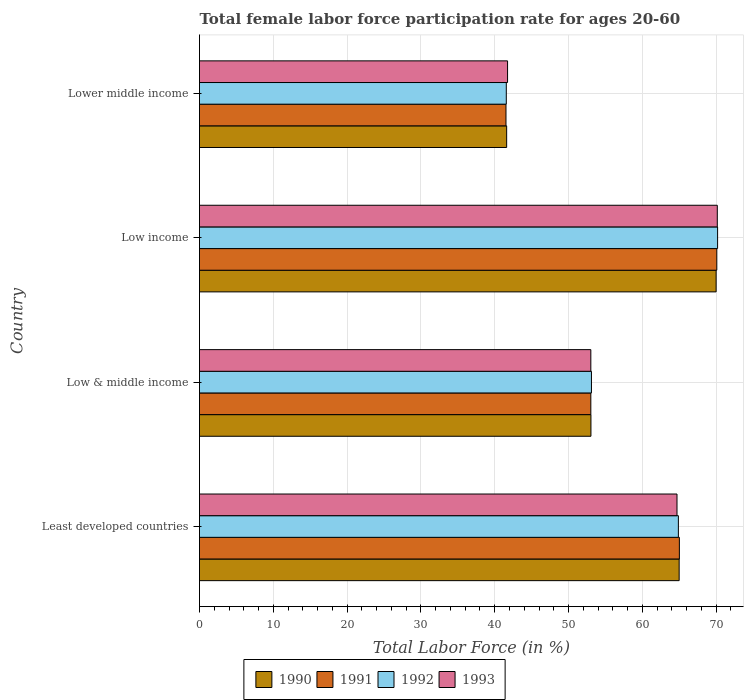How many different coloured bars are there?
Offer a terse response. 4. Are the number of bars per tick equal to the number of legend labels?
Your answer should be very brief. Yes. How many bars are there on the 3rd tick from the bottom?
Offer a very short reply. 4. In how many cases, is the number of bars for a given country not equal to the number of legend labels?
Offer a terse response. 0. What is the female labor force participation rate in 1991 in Lower middle income?
Your response must be concise. 41.53. Across all countries, what is the maximum female labor force participation rate in 1993?
Your answer should be very brief. 70.16. Across all countries, what is the minimum female labor force participation rate in 1990?
Your response must be concise. 41.62. In which country was the female labor force participation rate in 1990 maximum?
Keep it short and to the point. Low income. In which country was the female labor force participation rate in 1993 minimum?
Provide a short and direct response. Lower middle income. What is the total female labor force participation rate in 1991 in the graph?
Your response must be concise. 229.66. What is the difference between the female labor force participation rate in 1990 in Low & middle income and that in Lower middle income?
Offer a very short reply. 11.42. What is the difference between the female labor force participation rate in 1992 in Lower middle income and the female labor force participation rate in 1993 in Low income?
Provide a short and direct response. -28.59. What is the average female labor force participation rate in 1991 per country?
Your answer should be compact. 57.41. What is the difference between the female labor force participation rate in 1990 and female labor force participation rate in 1993 in Low income?
Your answer should be compact. -0.16. What is the ratio of the female labor force participation rate in 1990 in Least developed countries to that in Lower middle income?
Keep it short and to the point. 1.56. Is the female labor force participation rate in 1993 in Least developed countries less than that in Low & middle income?
Your response must be concise. No. What is the difference between the highest and the second highest female labor force participation rate in 1991?
Make the answer very short. 5.07. What is the difference between the highest and the lowest female labor force participation rate in 1990?
Offer a terse response. 28.38. What does the 2nd bar from the top in Least developed countries represents?
Offer a very short reply. 1992. What does the 1st bar from the bottom in Least developed countries represents?
Ensure brevity in your answer.  1990. How many countries are there in the graph?
Offer a terse response. 4. Does the graph contain any zero values?
Ensure brevity in your answer.  No. Does the graph contain grids?
Ensure brevity in your answer.  Yes. How many legend labels are there?
Offer a terse response. 4. How are the legend labels stacked?
Ensure brevity in your answer.  Horizontal. What is the title of the graph?
Make the answer very short. Total female labor force participation rate for ages 20-60. Does "1971" appear as one of the legend labels in the graph?
Provide a short and direct response. No. What is the label or title of the X-axis?
Make the answer very short. Total Labor Force (in %). What is the Total Labor Force (in %) of 1990 in Least developed countries?
Provide a succinct answer. 64.99. What is the Total Labor Force (in %) in 1991 in Least developed countries?
Ensure brevity in your answer.  65.02. What is the Total Labor Force (in %) of 1992 in Least developed countries?
Provide a short and direct response. 64.88. What is the Total Labor Force (in %) of 1993 in Least developed countries?
Keep it short and to the point. 64.7. What is the Total Labor Force (in %) of 1990 in Low & middle income?
Keep it short and to the point. 53.04. What is the Total Labor Force (in %) in 1991 in Low & middle income?
Your answer should be very brief. 53.02. What is the Total Labor Force (in %) in 1992 in Low & middle income?
Keep it short and to the point. 53.11. What is the Total Labor Force (in %) of 1993 in Low & middle income?
Your answer should be very brief. 53.02. What is the Total Labor Force (in %) in 1990 in Low income?
Make the answer very short. 70. What is the Total Labor Force (in %) of 1991 in Low income?
Provide a succinct answer. 70.09. What is the Total Labor Force (in %) in 1992 in Low income?
Ensure brevity in your answer.  70.2. What is the Total Labor Force (in %) of 1993 in Low income?
Provide a short and direct response. 70.16. What is the Total Labor Force (in %) of 1990 in Lower middle income?
Ensure brevity in your answer.  41.62. What is the Total Labor Force (in %) in 1991 in Lower middle income?
Ensure brevity in your answer.  41.53. What is the Total Labor Force (in %) of 1992 in Lower middle income?
Give a very brief answer. 41.57. What is the Total Labor Force (in %) in 1993 in Lower middle income?
Your response must be concise. 41.74. Across all countries, what is the maximum Total Labor Force (in %) of 1990?
Your response must be concise. 70. Across all countries, what is the maximum Total Labor Force (in %) in 1991?
Provide a short and direct response. 70.09. Across all countries, what is the maximum Total Labor Force (in %) of 1992?
Offer a terse response. 70.2. Across all countries, what is the maximum Total Labor Force (in %) in 1993?
Your answer should be compact. 70.16. Across all countries, what is the minimum Total Labor Force (in %) of 1990?
Offer a terse response. 41.62. Across all countries, what is the minimum Total Labor Force (in %) in 1991?
Ensure brevity in your answer.  41.53. Across all countries, what is the minimum Total Labor Force (in %) of 1992?
Give a very brief answer. 41.57. Across all countries, what is the minimum Total Labor Force (in %) of 1993?
Your answer should be very brief. 41.74. What is the total Total Labor Force (in %) in 1990 in the graph?
Your response must be concise. 229.64. What is the total Total Labor Force (in %) in 1991 in the graph?
Offer a very short reply. 229.66. What is the total Total Labor Force (in %) of 1992 in the graph?
Your answer should be very brief. 229.76. What is the total Total Labor Force (in %) in 1993 in the graph?
Make the answer very short. 229.62. What is the difference between the Total Labor Force (in %) in 1990 in Least developed countries and that in Low & middle income?
Provide a short and direct response. 11.95. What is the difference between the Total Labor Force (in %) in 1991 in Least developed countries and that in Low & middle income?
Offer a terse response. 12. What is the difference between the Total Labor Force (in %) in 1992 in Least developed countries and that in Low & middle income?
Offer a terse response. 11.78. What is the difference between the Total Labor Force (in %) in 1993 in Least developed countries and that in Low & middle income?
Provide a short and direct response. 11.68. What is the difference between the Total Labor Force (in %) in 1990 in Least developed countries and that in Low income?
Give a very brief answer. -5.01. What is the difference between the Total Labor Force (in %) in 1991 in Least developed countries and that in Low income?
Your answer should be compact. -5.07. What is the difference between the Total Labor Force (in %) in 1992 in Least developed countries and that in Low income?
Give a very brief answer. -5.31. What is the difference between the Total Labor Force (in %) of 1993 in Least developed countries and that in Low income?
Your answer should be compact. -5.46. What is the difference between the Total Labor Force (in %) in 1990 in Least developed countries and that in Lower middle income?
Provide a short and direct response. 23.37. What is the difference between the Total Labor Force (in %) in 1991 in Least developed countries and that in Lower middle income?
Your answer should be compact. 23.49. What is the difference between the Total Labor Force (in %) of 1992 in Least developed countries and that in Lower middle income?
Provide a succinct answer. 23.32. What is the difference between the Total Labor Force (in %) in 1993 in Least developed countries and that in Lower middle income?
Your response must be concise. 22.96. What is the difference between the Total Labor Force (in %) of 1990 in Low & middle income and that in Low income?
Make the answer very short. -16.96. What is the difference between the Total Labor Force (in %) in 1991 in Low & middle income and that in Low income?
Ensure brevity in your answer.  -17.07. What is the difference between the Total Labor Force (in %) in 1992 in Low & middle income and that in Low income?
Give a very brief answer. -17.09. What is the difference between the Total Labor Force (in %) of 1993 in Low & middle income and that in Low income?
Give a very brief answer. -17.14. What is the difference between the Total Labor Force (in %) of 1990 in Low & middle income and that in Lower middle income?
Your answer should be compact. 11.42. What is the difference between the Total Labor Force (in %) in 1991 in Low & middle income and that in Lower middle income?
Ensure brevity in your answer.  11.5. What is the difference between the Total Labor Force (in %) in 1992 in Low & middle income and that in Lower middle income?
Offer a terse response. 11.54. What is the difference between the Total Labor Force (in %) in 1993 in Low & middle income and that in Lower middle income?
Keep it short and to the point. 11.28. What is the difference between the Total Labor Force (in %) of 1990 in Low income and that in Lower middle income?
Provide a short and direct response. 28.38. What is the difference between the Total Labor Force (in %) of 1991 in Low income and that in Lower middle income?
Make the answer very short. 28.57. What is the difference between the Total Labor Force (in %) in 1992 in Low income and that in Lower middle income?
Keep it short and to the point. 28.63. What is the difference between the Total Labor Force (in %) in 1993 in Low income and that in Lower middle income?
Offer a very short reply. 28.42. What is the difference between the Total Labor Force (in %) of 1990 in Least developed countries and the Total Labor Force (in %) of 1991 in Low & middle income?
Offer a very short reply. 11.97. What is the difference between the Total Labor Force (in %) in 1990 in Least developed countries and the Total Labor Force (in %) in 1992 in Low & middle income?
Your answer should be compact. 11.88. What is the difference between the Total Labor Force (in %) of 1990 in Least developed countries and the Total Labor Force (in %) of 1993 in Low & middle income?
Provide a short and direct response. 11.97. What is the difference between the Total Labor Force (in %) of 1991 in Least developed countries and the Total Labor Force (in %) of 1992 in Low & middle income?
Ensure brevity in your answer.  11.91. What is the difference between the Total Labor Force (in %) in 1991 in Least developed countries and the Total Labor Force (in %) in 1993 in Low & middle income?
Offer a terse response. 12. What is the difference between the Total Labor Force (in %) in 1992 in Least developed countries and the Total Labor Force (in %) in 1993 in Low & middle income?
Provide a short and direct response. 11.86. What is the difference between the Total Labor Force (in %) of 1990 in Least developed countries and the Total Labor Force (in %) of 1991 in Low income?
Give a very brief answer. -5.1. What is the difference between the Total Labor Force (in %) of 1990 in Least developed countries and the Total Labor Force (in %) of 1992 in Low income?
Your answer should be compact. -5.21. What is the difference between the Total Labor Force (in %) of 1990 in Least developed countries and the Total Labor Force (in %) of 1993 in Low income?
Your answer should be compact. -5.17. What is the difference between the Total Labor Force (in %) in 1991 in Least developed countries and the Total Labor Force (in %) in 1992 in Low income?
Keep it short and to the point. -5.18. What is the difference between the Total Labor Force (in %) in 1991 in Least developed countries and the Total Labor Force (in %) in 1993 in Low income?
Make the answer very short. -5.14. What is the difference between the Total Labor Force (in %) of 1992 in Least developed countries and the Total Labor Force (in %) of 1993 in Low income?
Ensure brevity in your answer.  -5.27. What is the difference between the Total Labor Force (in %) in 1990 in Least developed countries and the Total Labor Force (in %) in 1991 in Lower middle income?
Provide a succinct answer. 23.46. What is the difference between the Total Labor Force (in %) of 1990 in Least developed countries and the Total Labor Force (in %) of 1992 in Lower middle income?
Provide a succinct answer. 23.42. What is the difference between the Total Labor Force (in %) in 1990 in Least developed countries and the Total Labor Force (in %) in 1993 in Lower middle income?
Offer a very short reply. 23.25. What is the difference between the Total Labor Force (in %) of 1991 in Least developed countries and the Total Labor Force (in %) of 1992 in Lower middle income?
Offer a very short reply. 23.45. What is the difference between the Total Labor Force (in %) in 1991 in Least developed countries and the Total Labor Force (in %) in 1993 in Lower middle income?
Ensure brevity in your answer.  23.28. What is the difference between the Total Labor Force (in %) of 1992 in Least developed countries and the Total Labor Force (in %) of 1993 in Lower middle income?
Provide a succinct answer. 23.14. What is the difference between the Total Labor Force (in %) in 1990 in Low & middle income and the Total Labor Force (in %) in 1991 in Low income?
Your answer should be very brief. -17.06. What is the difference between the Total Labor Force (in %) in 1990 in Low & middle income and the Total Labor Force (in %) in 1992 in Low income?
Provide a succinct answer. -17.16. What is the difference between the Total Labor Force (in %) in 1990 in Low & middle income and the Total Labor Force (in %) in 1993 in Low income?
Make the answer very short. -17.12. What is the difference between the Total Labor Force (in %) of 1991 in Low & middle income and the Total Labor Force (in %) of 1992 in Low income?
Your answer should be compact. -17.18. What is the difference between the Total Labor Force (in %) in 1991 in Low & middle income and the Total Labor Force (in %) in 1993 in Low income?
Provide a succinct answer. -17.14. What is the difference between the Total Labor Force (in %) of 1992 in Low & middle income and the Total Labor Force (in %) of 1993 in Low income?
Make the answer very short. -17.05. What is the difference between the Total Labor Force (in %) in 1990 in Low & middle income and the Total Labor Force (in %) in 1991 in Lower middle income?
Keep it short and to the point. 11.51. What is the difference between the Total Labor Force (in %) of 1990 in Low & middle income and the Total Labor Force (in %) of 1992 in Lower middle income?
Ensure brevity in your answer.  11.47. What is the difference between the Total Labor Force (in %) in 1990 in Low & middle income and the Total Labor Force (in %) in 1993 in Lower middle income?
Make the answer very short. 11.3. What is the difference between the Total Labor Force (in %) in 1991 in Low & middle income and the Total Labor Force (in %) in 1992 in Lower middle income?
Offer a terse response. 11.45. What is the difference between the Total Labor Force (in %) in 1991 in Low & middle income and the Total Labor Force (in %) in 1993 in Lower middle income?
Make the answer very short. 11.28. What is the difference between the Total Labor Force (in %) of 1992 in Low & middle income and the Total Labor Force (in %) of 1993 in Lower middle income?
Your response must be concise. 11.37. What is the difference between the Total Labor Force (in %) in 1990 in Low income and the Total Labor Force (in %) in 1991 in Lower middle income?
Your answer should be very brief. 28.47. What is the difference between the Total Labor Force (in %) of 1990 in Low income and the Total Labor Force (in %) of 1992 in Lower middle income?
Ensure brevity in your answer.  28.43. What is the difference between the Total Labor Force (in %) in 1990 in Low income and the Total Labor Force (in %) in 1993 in Lower middle income?
Offer a very short reply. 28.26. What is the difference between the Total Labor Force (in %) in 1991 in Low income and the Total Labor Force (in %) in 1992 in Lower middle income?
Keep it short and to the point. 28.52. What is the difference between the Total Labor Force (in %) in 1991 in Low income and the Total Labor Force (in %) in 1993 in Lower middle income?
Provide a short and direct response. 28.35. What is the difference between the Total Labor Force (in %) of 1992 in Low income and the Total Labor Force (in %) of 1993 in Lower middle income?
Give a very brief answer. 28.46. What is the average Total Labor Force (in %) of 1990 per country?
Make the answer very short. 57.41. What is the average Total Labor Force (in %) of 1991 per country?
Provide a succinct answer. 57.41. What is the average Total Labor Force (in %) of 1992 per country?
Your answer should be compact. 57.44. What is the average Total Labor Force (in %) of 1993 per country?
Your response must be concise. 57.4. What is the difference between the Total Labor Force (in %) in 1990 and Total Labor Force (in %) in 1991 in Least developed countries?
Offer a terse response. -0.03. What is the difference between the Total Labor Force (in %) of 1990 and Total Labor Force (in %) of 1992 in Least developed countries?
Offer a very short reply. 0.1. What is the difference between the Total Labor Force (in %) in 1990 and Total Labor Force (in %) in 1993 in Least developed countries?
Your answer should be compact. 0.29. What is the difference between the Total Labor Force (in %) in 1991 and Total Labor Force (in %) in 1992 in Least developed countries?
Provide a succinct answer. 0.14. What is the difference between the Total Labor Force (in %) in 1991 and Total Labor Force (in %) in 1993 in Least developed countries?
Provide a succinct answer. 0.32. What is the difference between the Total Labor Force (in %) in 1992 and Total Labor Force (in %) in 1993 in Least developed countries?
Provide a succinct answer. 0.19. What is the difference between the Total Labor Force (in %) in 1990 and Total Labor Force (in %) in 1991 in Low & middle income?
Offer a terse response. 0.02. What is the difference between the Total Labor Force (in %) of 1990 and Total Labor Force (in %) of 1992 in Low & middle income?
Your answer should be compact. -0.07. What is the difference between the Total Labor Force (in %) of 1990 and Total Labor Force (in %) of 1993 in Low & middle income?
Offer a terse response. 0.02. What is the difference between the Total Labor Force (in %) in 1991 and Total Labor Force (in %) in 1992 in Low & middle income?
Ensure brevity in your answer.  -0.09. What is the difference between the Total Labor Force (in %) in 1991 and Total Labor Force (in %) in 1993 in Low & middle income?
Ensure brevity in your answer.  0. What is the difference between the Total Labor Force (in %) of 1992 and Total Labor Force (in %) of 1993 in Low & middle income?
Your answer should be compact. 0.09. What is the difference between the Total Labor Force (in %) of 1990 and Total Labor Force (in %) of 1991 in Low income?
Give a very brief answer. -0.09. What is the difference between the Total Labor Force (in %) of 1990 and Total Labor Force (in %) of 1992 in Low income?
Provide a succinct answer. -0.2. What is the difference between the Total Labor Force (in %) in 1990 and Total Labor Force (in %) in 1993 in Low income?
Your answer should be compact. -0.16. What is the difference between the Total Labor Force (in %) of 1991 and Total Labor Force (in %) of 1992 in Low income?
Your answer should be very brief. -0.1. What is the difference between the Total Labor Force (in %) in 1991 and Total Labor Force (in %) in 1993 in Low income?
Ensure brevity in your answer.  -0.06. What is the difference between the Total Labor Force (in %) of 1992 and Total Labor Force (in %) of 1993 in Low income?
Offer a very short reply. 0.04. What is the difference between the Total Labor Force (in %) in 1990 and Total Labor Force (in %) in 1991 in Lower middle income?
Your answer should be very brief. 0.09. What is the difference between the Total Labor Force (in %) in 1990 and Total Labor Force (in %) in 1992 in Lower middle income?
Provide a short and direct response. 0.05. What is the difference between the Total Labor Force (in %) of 1990 and Total Labor Force (in %) of 1993 in Lower middle income?
Your answer should be very brief. -0.12. What is the difference between the Total Labor Force (in %) of 1991 and Total Labor Force (in %) of 1992 in Lower middle income?
Give a very brief answer. -0.04. What is the difference between the Total Labor Force (in %) of 1991 and Total Labor Force (in %) of 1993 in Lower middle income?
Your response must be concise. -0.21. What is the difference between the Total Labor Force (in %) in 1992 and Total Labor Force (in %) in 1993 in Lower middle income?
Provide a short and direct response. -0.17. What is the ratio of the Total Labor Force (in %) in 1990 in Least developed countries to that in Low & middle income?
Provide a succinct answer. 1.23. What is the ratio of the Total Labor Force (in %) in 1991 in Least developed countries to that in Low & middle income?
Your answer should be very brief. 1.23. What is the ratio of the Total Labor Force (in %) in 1992 in Least developed countries to that in Low & middle income?
Your response must be concise. 1.22. What is the ratio of the Total Labor Force (in %) in 1993 in Least developed countries to that in Low & middle income?
Make the answer very short. 1.22. What is the ratio of the Total Labor Force (in %) in 1990 in Least developed countries to that in Low income?
Offer a terse response. 0.93. What is the ratio of the Total Labor Force (in %) of 1991 in Least developed countries to that in Low income?
Ensure brevity in your answer.  0.93. What is the ratio of the Total Labor Force (in %) of 1992 in Least developed countries to that in Low income?
Make the answer very short. 0.92. What is the ratio of the Total Labor Force (in %) of 1993 in Least developed countries to that in Low income?
Offer a terse response. 0.92. What is the ratio of the Total Labor Force (in %) of 1990 in Least developed countries to that in Lower middle income?
Your response must be concise. 1.56. What is the ratio of the Total Labor Force (in %) in 1991 in Least developed countries to that in Lower middle income?
Offer a very short reply. 1.57. What is the ratio of the Total Labor Force (in %) of 1992 in Least developed countries to that in Lower middle income?
Provide a short and direct response. 1.56. What is the ratio of the Total Labor Force (in %) of 1993 in Least developed countries to that in Lower middle income?
Keep it short and to the point. 1.55. What is the ratio of the Total Labor Force (in %) in 1990 in Low & middle income to that in Low income?
Your answer should be compact. 0.76. What is the ratio of the Total Labor Force (in %) in 1991 in Low & middle income to that in Low income?
Make the answer very short. 0.76. What is the ratio of the Total Labor Force (in %) in 1992 in Low & middle income to that in Low income?
Ensure brevity in your answer.  0.76. What is the ratio of the Total Labor Force (in %) of 1993 in Low & middle income to that in Low income?
Your response must be concise. 0.76. What is the ratio of the Total Labor Force (in %) of 1990 in Low & middle income to that in Lower middle income?
Offer a very short reply. 1.27. What is the ratio of the Total Labor Force (in %) in 1991 in Low & middle income to that in Lower middle income?
Your response must be concise. 1.28. What is the ratio of the Total Labor Force (in %) of 1992 in Low & middle income to that in Lower middle income?
Make the answer very short. 1.28. What is the ratio of the Total Labor Force (in %) of 1993 in Low & middle income to that in Lower middle income?
Keep it short and to the point. 1.27. What is the ratio of the Total Labor Force (in %) of 1990 in Low income to that in Lower middle income?
Make the answer very short. 1.68. What is the ratio of the Total Labor Force (in %) of 1991 in Low income to that in Lower middle income?
Provide a succinct answer. 1.69. What is the ratio of the Total Labor Force (in %) of 1992 in Low income to that in Lower middle income?
Offer a terse response. 1.69. What is the ratio of the Total Labor Force (in %) in 1993 in Low income to that in Lower middle income?
Your answer should be very brief. 1.68. What is the difference between the highest and the second highest Total Labor Force (in %) in 1990?
Keep it short and to the point. 5.01. What is the difference between the highest and the second highest Total Labor Force (in %) of 1991?
Your answer should be compact. 5.07. What is the difference between the highest and the second highest Total Labor Force (in %) of 1992?
Provide a short and direct response. 5.31. What is the difference between the highest and the second highest Total Labor Force (in %) in 1993?
Make the answer very short. 5.46. What is the difference between the highest and the lowest Total Labor Force (in %) of 1990?
Offer a terse response. 28.38. What is the difference between the highest and the lowest Total Labor Force (in %) of 1991?
Provide a succinct answer. 28.57. What is the difference between the highest and the lowest Total Labor Force (in %) of 1992?
Keep it short and to the point. 28.63. What is the difference between the highest and the lowest Total Labor Force (in %) of 1993?
Your response must be concise. 28.42. 